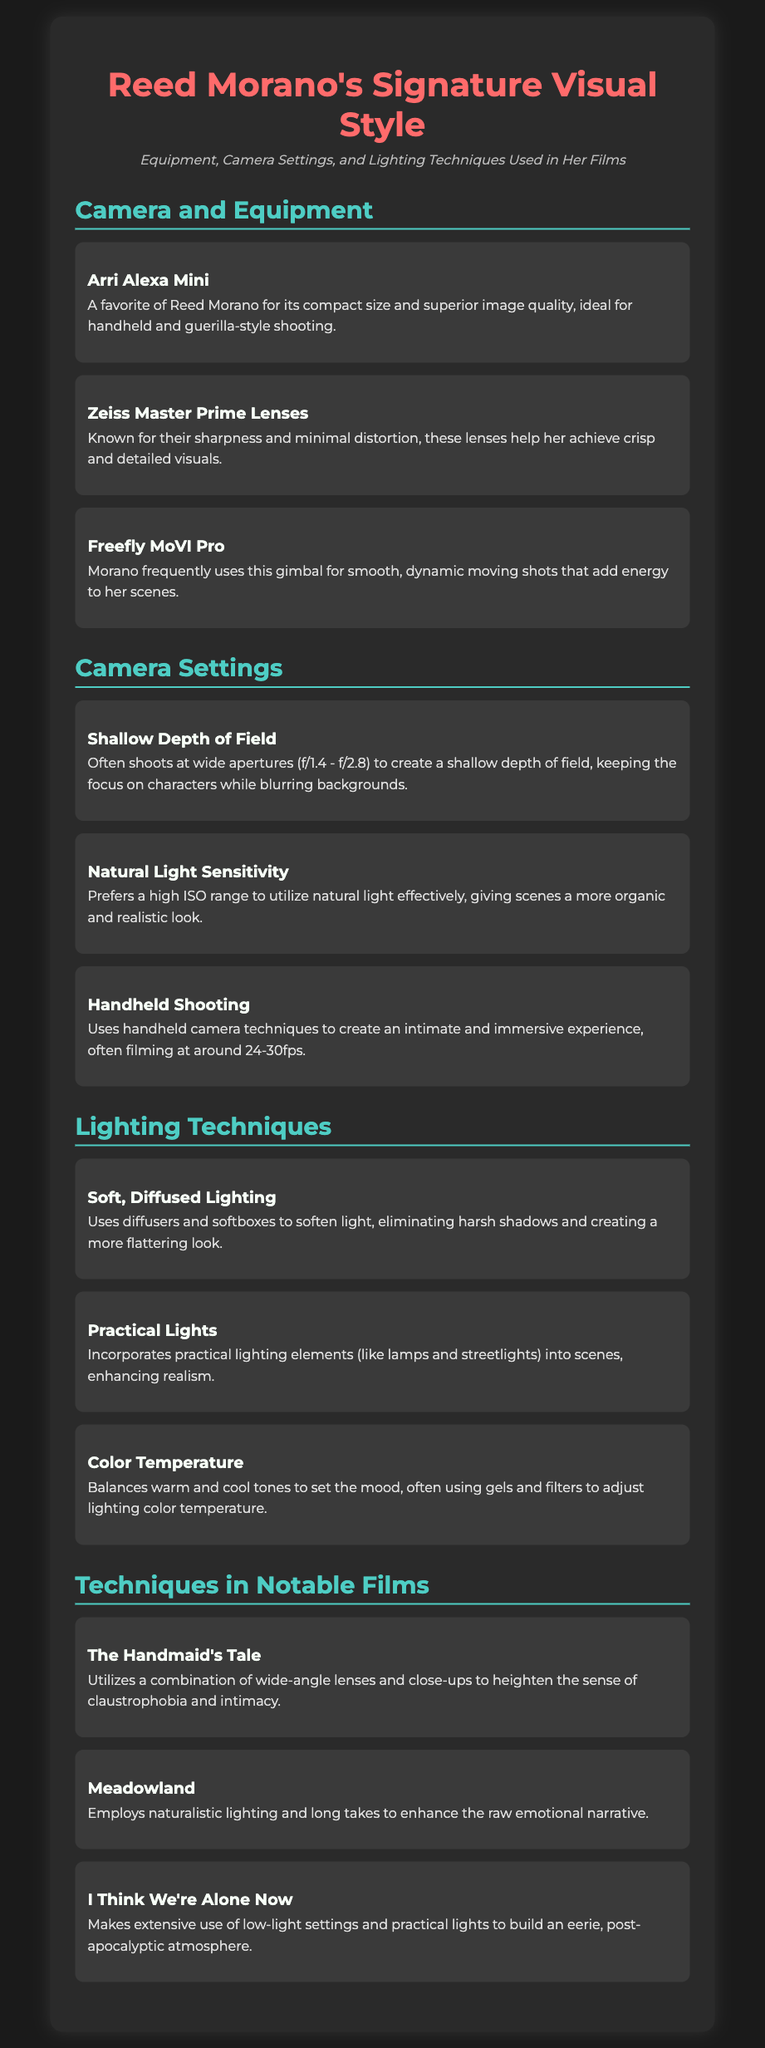What camera does Reed Morano favor? The document specifies that Reed Morano's favorite camera is the Arri Alexa Mini.
Answer: Arri Alexa Mini What type of lenses does she use? The document mentions that she uses Zeiss Master Prime Lenses for their sharpness.
Answer: Zeiss Master Prime Lenses What camera setting does she often shoot with for a shallow depth of field? It states that she typically uses wide apertures, particularly f/1.4 to f/2.8.
Answer: f/1.4 - f/2.8 Which lighting technique does Morano use to eliminate harsh shadows? The document indicates she uses soft, diffused lighting achieved through diffusers and softboxes.
Answer: Soft, Diffused Lighting What mood does Morano create in "I Think We're Alone Now"? It mentions she builds an eerie, post-apocalyptic atmosphere through low-light settings and practical lights.
Answer: Eerie, post-apocalyptic atmosphere How does she achieve an intimate shooting style? The document explains that she employs handheld shooting techniques to enhance intimacy.
Answer: Handheld shooting What is a notable series directed by Reed Morano? The document notes that "The Handmaid's Tale" is one of her notable works.
Answer: The Handmaid's Tale What equipment does Morano use for dynamic moving shots? The document highlights her frequent use of the Freefly MoVI Pro for such shots.
Answer: Freefly MoVI Pro How does she balance warm and cool tones in her lighting? It states that she uses gels and filters to adjust the lighting color temperature.
Answer: Gels and filters 